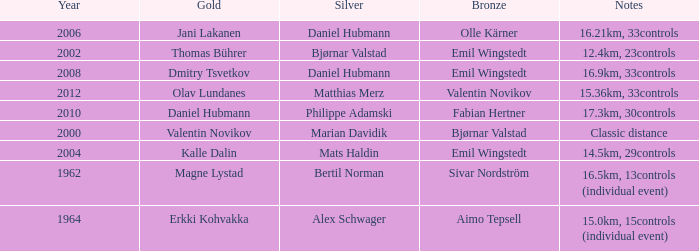WHAT IS THE YEAR WITH A BRONZE OF AIMO TEPSELL? 1964.0. 